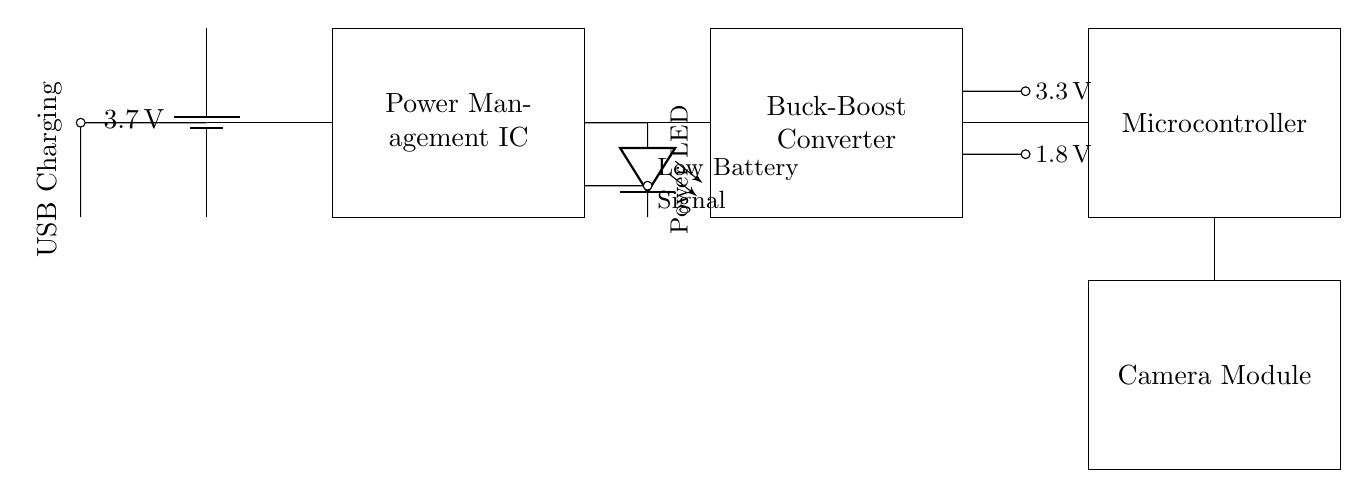What is the type of the battery? The battery is a lithium-ion type, indicated by the label "3.7 V" on the battery symbol in the circuit.
Answer: lithium-ion What does the power management IC do? The power management IC regulates the power supply to the rest of the circuit, distributing power efficiently from the battery to the Buck-Boost Converter.
Answer: regulates power What voltage does the Buck-Boost Converter output? The Buck-Boost Converter has two voltage outputs: one is 3.3 volts and the other is 1.8 volts, as shown by the markings near the output connections.
Answer: 3.3 volts, 1.8 volts What does the LED indicate in the circuit? The LED, denoted as "Power LED," visually indicates the status of power in the device. It lights up when the device is receiving power.
Answer: power status How does the system detect low battery? The circuit includes a detection line labeled "Low Battery Signal," which signals the microcontroller when the battery voltage falls below a certain threshold. This circuit connection activates when the voltage is low.
Answer: low battery detection How does the USB charging port connect to the battery? The USB Charging Port connects directly to the battery, allowing external power via the short connection shown to the battery's positive terminal. This facilitates charging when the device is connected to a USB power source.
Answer: direct connection 